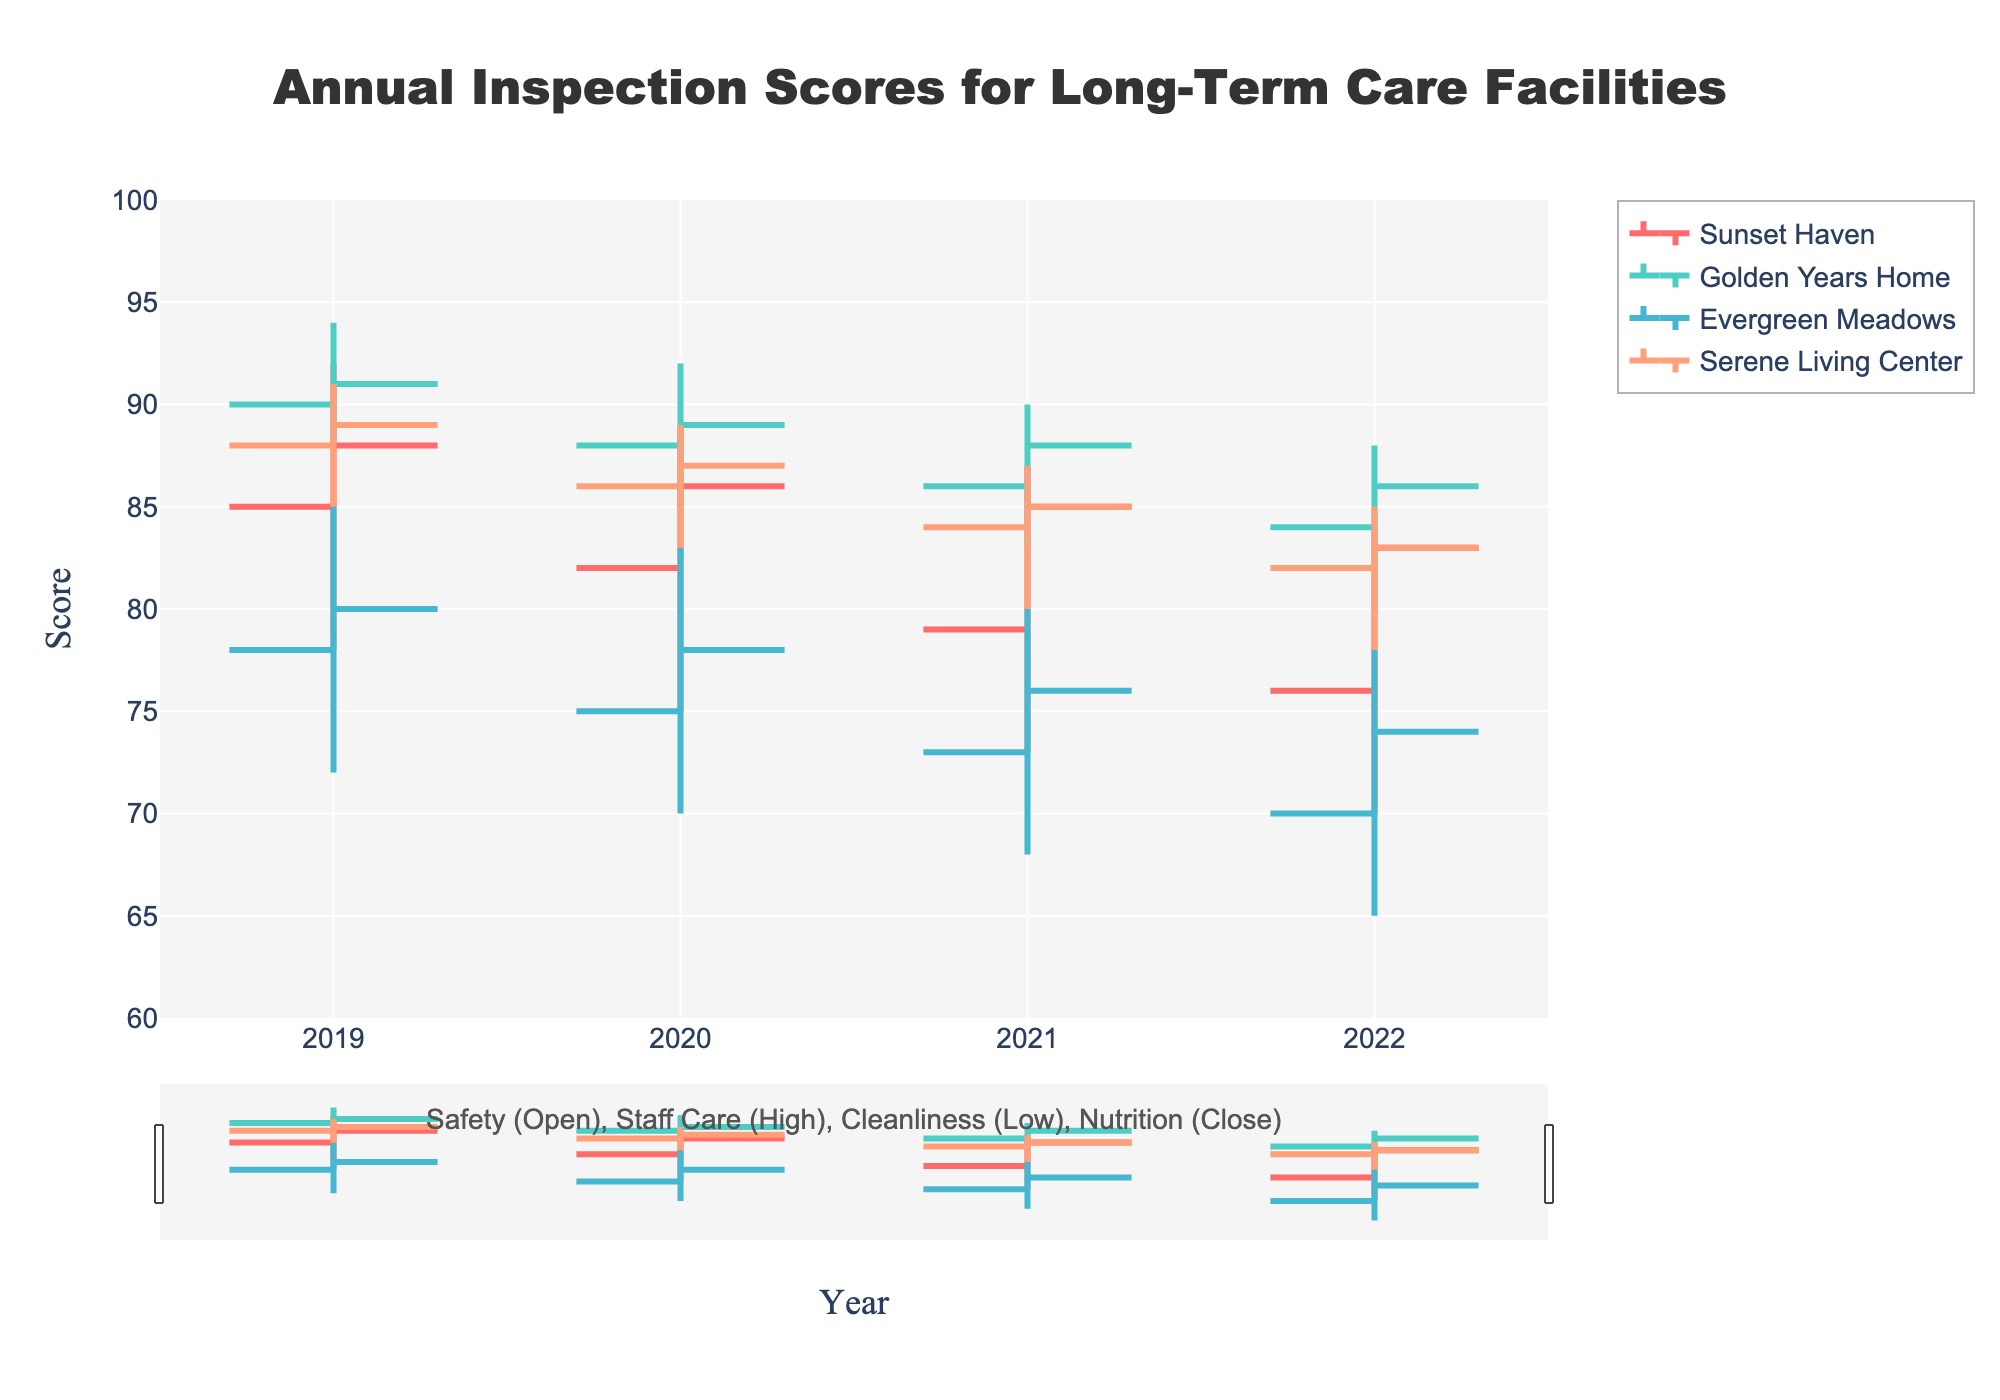What's the title of the plot? The title of the plot can be found at the top-center of the figure. It reads "Annual Inspection Scores for Long-Term Care Facilities."
Answer: Annual Inspection Scores for Long-Term Care Facilities Which evaluation category is represented by the open values in the chart? The annotation below the chart explains that the open values correspond to the Safety evaluation category.
Answer: Safety What was the safety score for Sunset Haven in 2021? To find this, look at the open value for Sunset Haven in 2021. The open value in an OHLC chart indicates the safety score, which is 79 for Sunset Haven in 2021.
Answer: 79 Which facility had the highest cleanliness score in 2019? Check the low values for the year 2019, as cleanliness is represented by low values. Golden Years Home and Serene Living Center both had the highest cleanliness score of 85 in 2019.
Answer: Golden Years Home and Serene Living Center What's the mean nutrition score for Serene Living Center from 2019 to 2022? To calculate the mean nutrition score, add the nutrition scores for each year (89 in 2019, 87 in 2020, 85 in 2021, and 83 in 2022) and divide by the number of years. (89 + 87 + 85 + 83) / 4 equals 86.
Answer: 86 Which facility showed a consistent decline in its safety score from 2019 to 2022? By looking at the trend in the open values for safety from 2019 to 2022, it's clear that Sunset Haven showed a consistent decline in its safety score.
Answer: Sunset Haven For Golden Years Home in 2021, did the nutrition score increase or decrease compared to 2020? Compare the close value for nutrition in 2021 to the close value in 2020 for Golden Years Home. The nutrition score decreased from 89 in 2020 to 88 in 2021.
Answer: Decrease Which facility had the highest staff care score in 2022? Look at the high values for 2022 to identify the highest staff care score. Golden Years Home had the highest staff care score of 88 in 2022.
Answer: Golden Years Home Was there a year when Evergreen Meadows' cleanliness score was above 70? By examining the low values for cleanliness for each year for Evergreen Meadows, it's clear that the cleanliness score was above 70 in 2019 (72) and 2020 (70).
Answer: Yes, in 2019 Compare the nutrition score trends between Golden Years Home and Serene Living Center from 2019 to 2022. Look at the close values for each year for both facilities. Golden Years Home's nutrition scores were 91, 89, 88, and 86, and Serene Living Center's scores were 89, 87, 85, and 83. Both facilities show a decreasing trend, but Golden Years Home started from a higher score and had a smaller total decline.
Answer: Both decreased, but Golden Years Home had a higher starting score and a smaller decline overall 